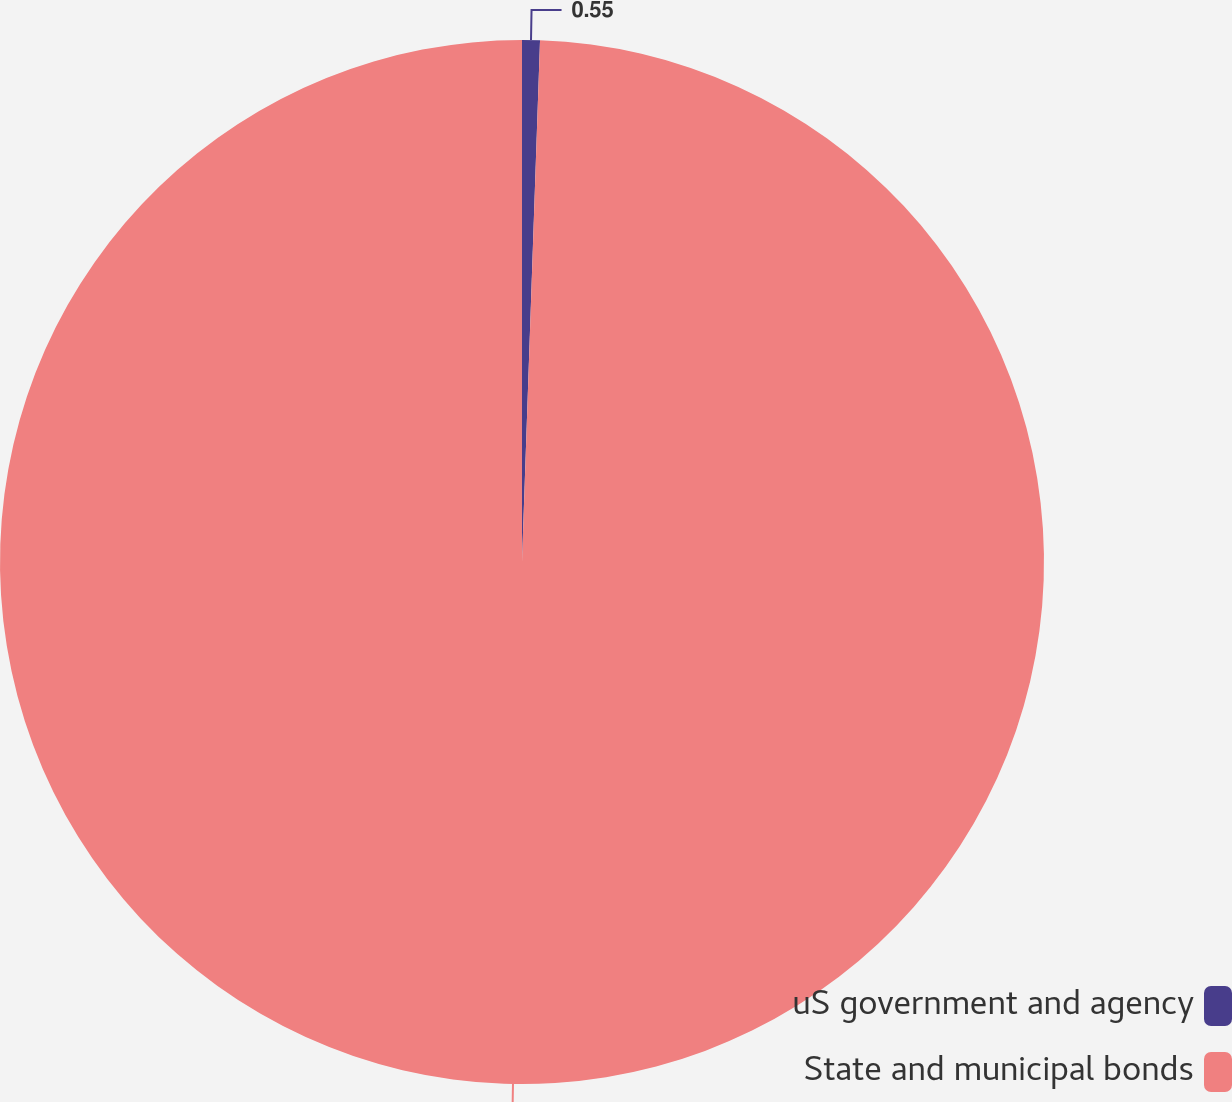Convert chart. <chart><loc_0><loc_0><loc_500><loc_500><pie_chart><fcel>uS government and agency<fcel>State and municipal bonds<nl><fcel>0.55%<fcel>99.45%<nl></chart> 